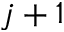Convert formula to latex. <formula><loc_0><loc_0><loc_500><loc_500>j + 1</formula> 